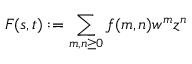Convert formula to latex. <formula><loc_0><loc_0><loc_500><loc_500>F ( s , t ) \colon = \sum _ { m , n \geq 0 } f ( m , n ) w ^ { m } z ^ { n }</formula> 